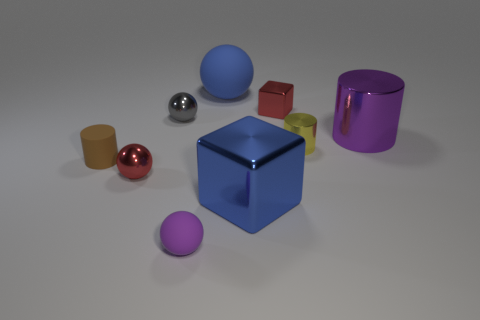Subtract all cubes. How many objects are left? 7 Add 2 large cylinders. How many large cylinders exist? 3 Subtract 0 gray cylinders. How many objects are left? 9 Subtract all tiny rubber cylinders. Subtract all big purple metal cylinders. How many objects are left? 7 Add 4 tiny red metal spheres. How many tiny red metal spheres are left? 5 